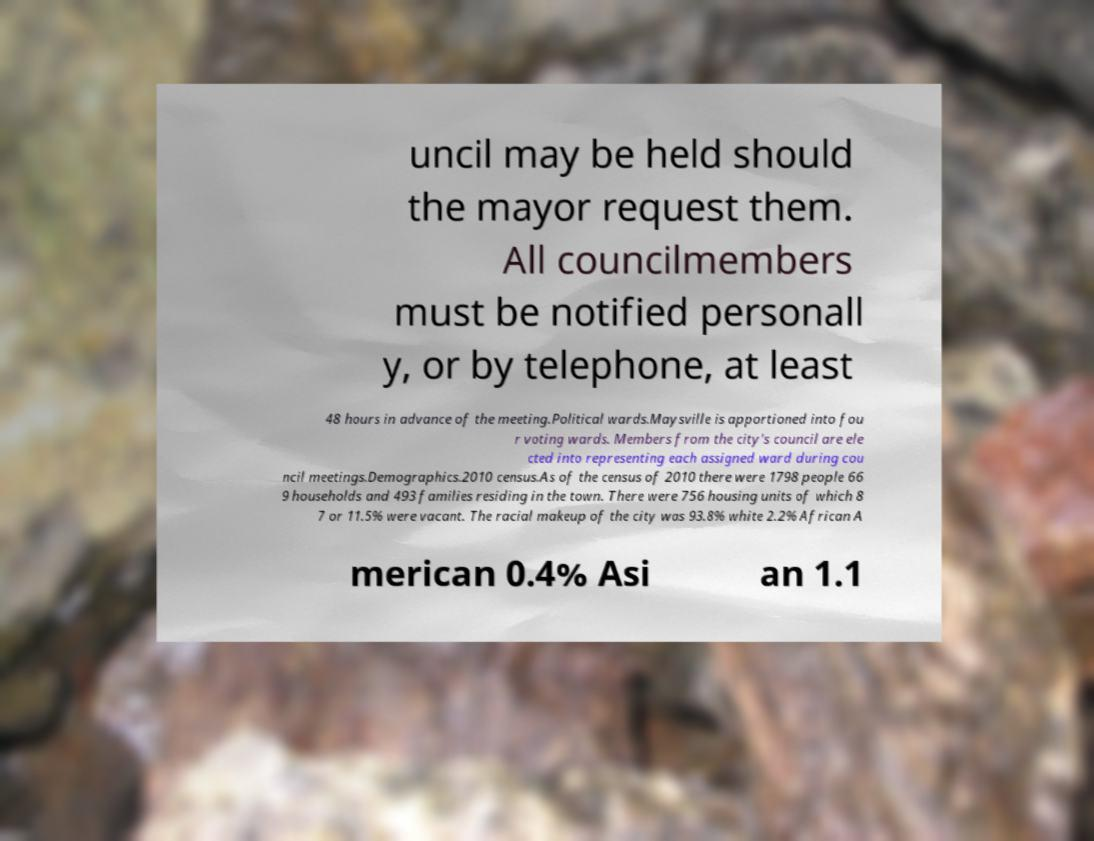Could you extract and type out the text from this image? uncil may be held should the mayor request them. All councilmembers must be notified personall y, or by telephone, at least 48 hours in advance of the meeting.Political wards.Maysville is apportioned into fou r voting wards. Members from the city's council are ele cted into representing each assigned ward during cou ncil meetings.Demographics.2010 census.As of the census of 2010 there were 1798 people 66 9 households and 493 families residing in the town. There were 756 housing units of which 8 7 or 11.5% were vacant. The racial makeup of the city was 93.8% white 2.2% African A merican 0.4% Asi an 1.1 